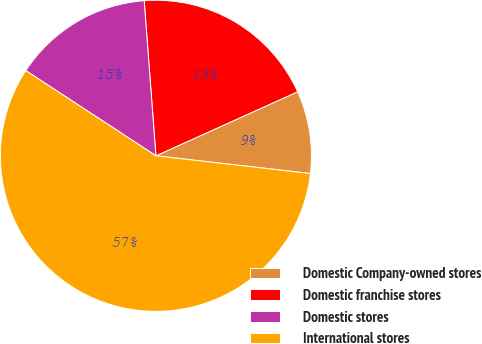Convert chart. <chart><loc_0><loc_0><loc_500><loc_500><pie_chart><fcel>Domestic Company-owned stores<fcel>Domestic franchise stores<fcel>Domestic stores<fcel>International stores<nl><fcel>8.57%<fcel>19.45%<fcel>14.57%<fcel>57.41%<nl></chart> 